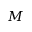Convert formula to latex. <formula><loc_0><loc_0><loc_500><loc_500>M</formula> 